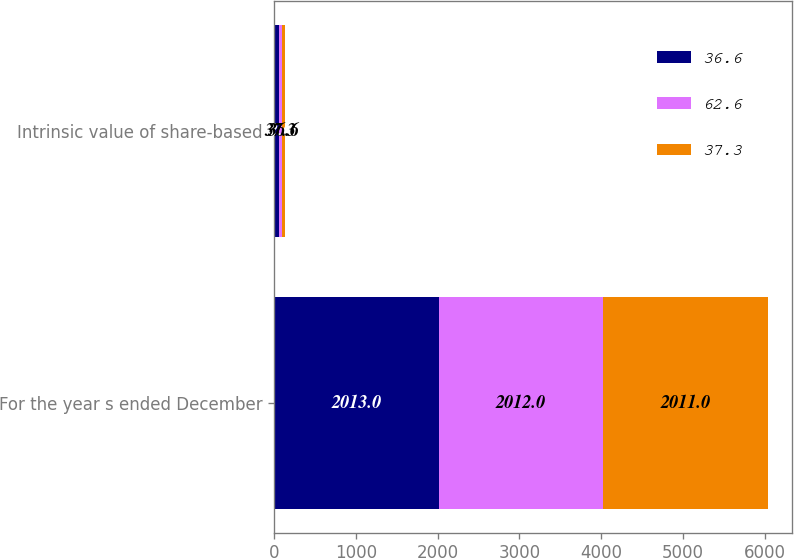Convert chart to OTSL. <chart><loc_0><loc_0><loc_500><loc_500><stacked_bar_chart><ecel><fcel>For the year s ended December<fcel>Intrinsic value of share-based<nl><fcel>36.6<fcel>2013<fcel>62.6<nl><fcel>62.6<fcel>2012<fcel>37.3<nl><fcel>37.3<fcel>2011<fcel>36.6<nl></chart> 